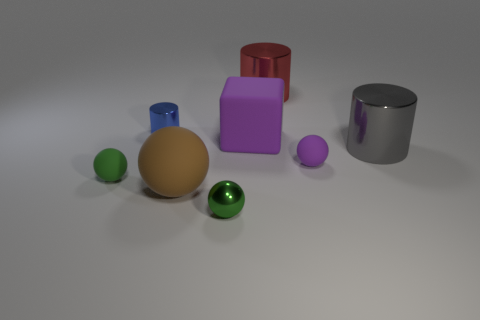Is there any other thing that is made of the same material as the big red cylinder?
Offer a terse response. Yes. Do the big matte thing that is behind the big gray thing and the red metallic thing have the same shape?
Your answer should be very brief. No. What is the material of the big block?
Offer a terse response. Rubber. What is the shape of the purple matte object that is right of the purple matte thing behind the cylinder in front of the purple matte cube?
Make the answer very short. Sphere. What number of other objects are the same shape as the big red metal object?
Your answer should be very brief. 2. Does the large block have the same color as the tiny rubber thing to the right of the big sphere?
Make the answer very short. Yes. How many gray cylinders are there?
Keep it short and to the point. 1. What number of things are either large yellow shiny blocks or small purple things?
Keep it short and to the point. 1. What size is the matte thing that is the same color as the matte block?
Keep it short and to the point. Small. There is a small purple matte object; are there any cylinders on the right side of it?
Offer a very short reply. Yes. 